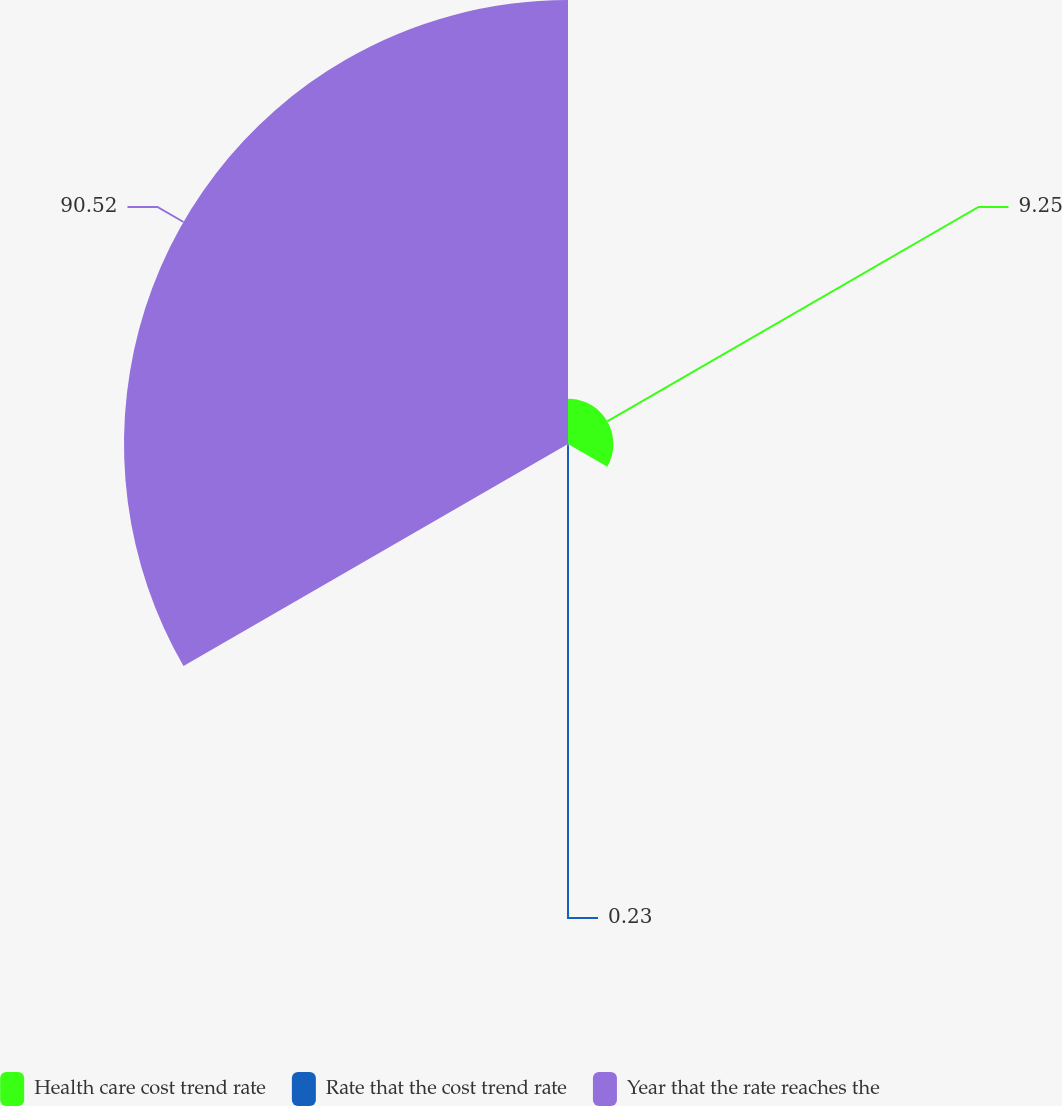Convert chart. <chart><loc_0><loc_0><loc_500><loc_500><pie_chart><fcel>Health care cost trend rate<fcel>Rate that the cost trend rate<fcel>Year that the rate reaches the<nl><fcel>9.25%<fcel>0.23%<fcel>90.52%<nl></chart> 